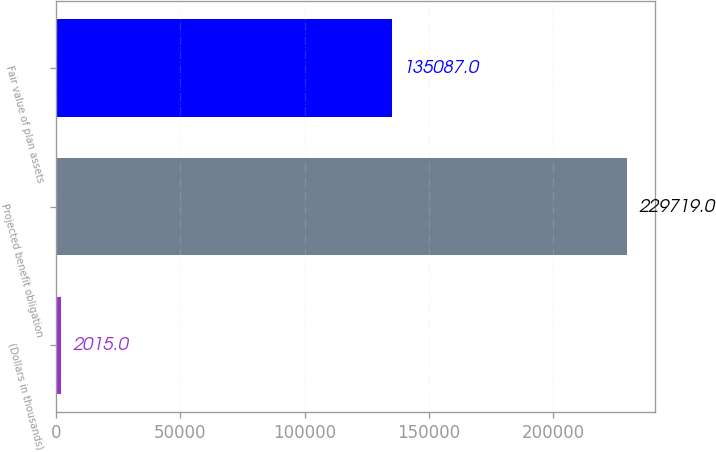Convert chart to OTSL. <chart><loc_0><loc_0><loc_500><loc_500><bar_chart><fcel>(Dollars in thousands)<fcel>Projected benefit obligation<fcel>Fair value of plan assets<nl><fcel>2015<fcel>229719<fcel>135087<nl></chart> 